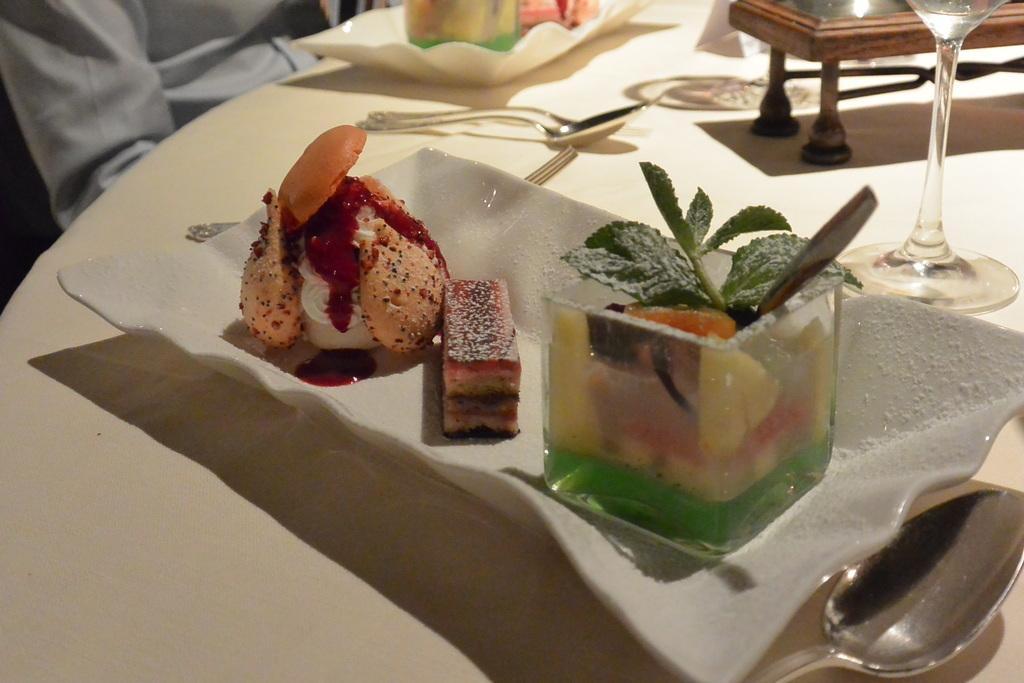Could you give a brief overview of what you see in this image? In the center of the image there is a table on which there are food items in a plate. There are spoons,glass. In the background of the image there is a person. 